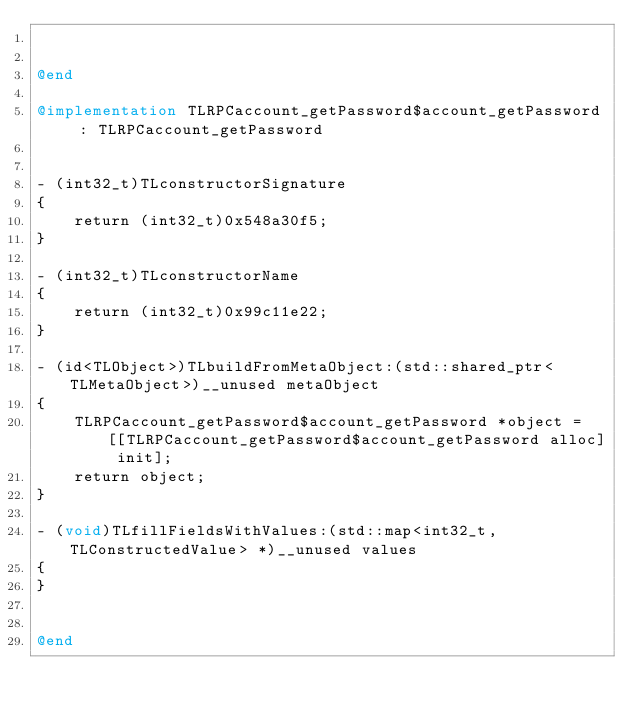Convert code to text. <code><loc_0><loc_0><loc_500><loc_500><_ObjectiveC_>

@end

@implementation TLRPCaccount_getPassword$account_getPassword : TLRPCaccount_getPassword


- (int32_t)TLconstructorSignature
{
    return (int32_t)0x548a30f5;
}

- (int32_t)TLconstructorName
{
    return (int32_t)0x99c11e22;
}

- (id<TLObject>)TLbuildFromMetaObject:(std::shared_ptr<TLMetaObject>)__unused metaObject
{
    TLRPCaccount_getPassword$account_getPassword *object = [[TLRPCaccount_getPassword$account_getPassword alloc] init];
    return object;
}

- (void)TLfillFieldsWithValues:(std::map<int32_t, TLConstructedValue> *)__unused values
{
}


@end

</code> 